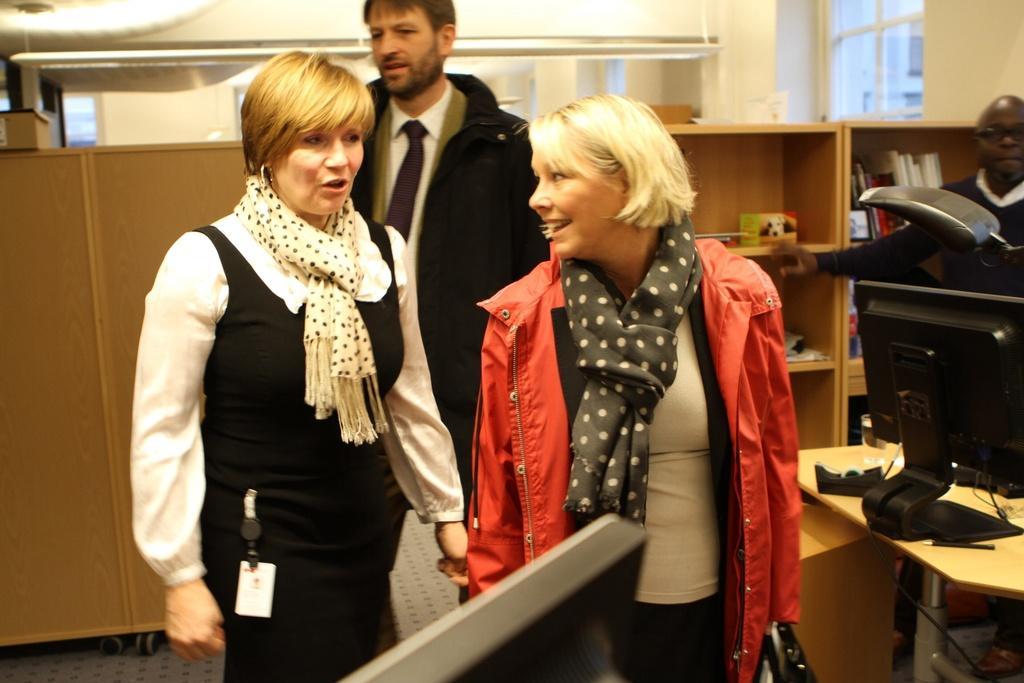How would you summarize this image in a sentence or two? In this image, we can see some people standing, at the right side there is a black color monitor on the table, in the background there are two racks. 